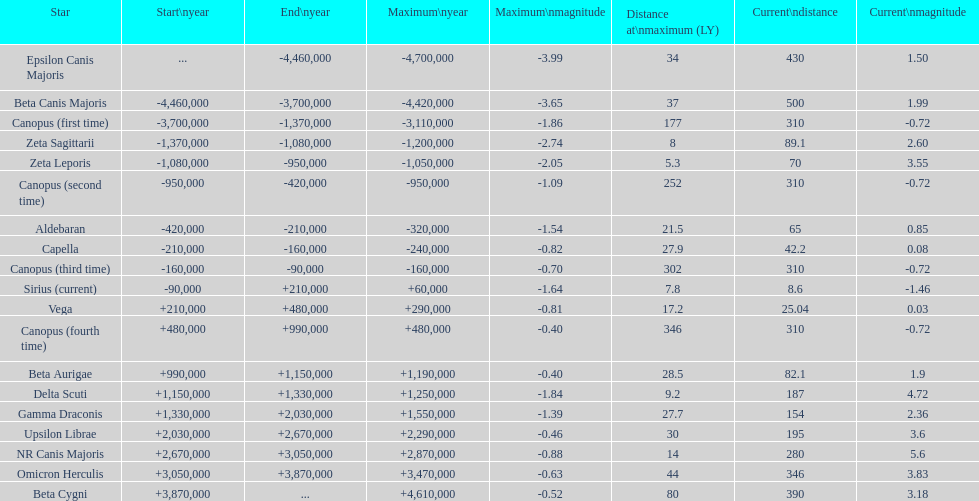What is the difference in distance (in ly) between epsilon canis majoris and zeta sagittarii? 26. 